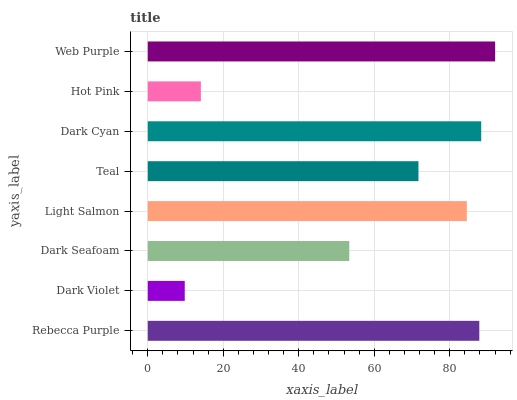Is Dark Violet the minimum?
Answer yes or no. Yes. Is Web Purple the maximum?
Answer yes or no. Yes. Is Dark Seafoam the minimum?
Answer yes or no. No. Is Dark Seafoam the maximum?
Answer yes or no. No. Is Dark Seafoam greater than Dark Violet?
Answer yes or no. Yes. Is Dark Violet less than Dark Seafoam?
Answer yes or no. Yes. Is Dark Violet greater than Dark Seafoam?
Answer yes or no. No. Is Dark Seafoam less than Dark Violet?
Answer yes or no. No. Is Light Salmon the high median?
Answer yes or no. Yes. Is Teal the low median?
Answer yes or no. Yes. Is Hot Pink the high median?
Answer yes or no. No. Is Rebecca Purple the low median?
Answer yes or no. No. 